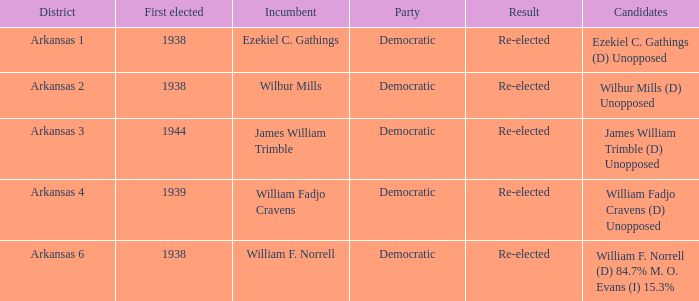I'm looking to parse the entire table for insights. Could you assist me with that? {'header': ['District', 'First elected', 'Incumbent', 'Party', 'Result', 'Candidates'], 'rows': [['Arkansas 1', '1938', 'Ezekiel C. Gathings', 'Democratic', 'Re-elected', 'Ezekiel C. Gathings (D) Unopposed'], ['Arkansas 2', '1938', 'Wilbur Mills', 'Democratic', 'Re-elected', 'Wilbur Mills (D) Unopposed'], ['Arkansas 3', '1944', 'James William Trimble', 'Democratic', 'Re-elected', 'James William Trimble (D) Unopposed'], ['Arkansas 4', '1939', 'William Fadjo Cravens', 'Democratic', 'Re-elected', 'William Fadjo Cravens (D) Unopposed'], ['Arkansas 6', '1938', 'William F. Norrell', 'Democratic', 'Re-elected', 'William F. Norrell (D) 84.7% M. O. Evans (I) 15.3%']]} How many were first elected in the Arkansas 4 district? 1.0. 